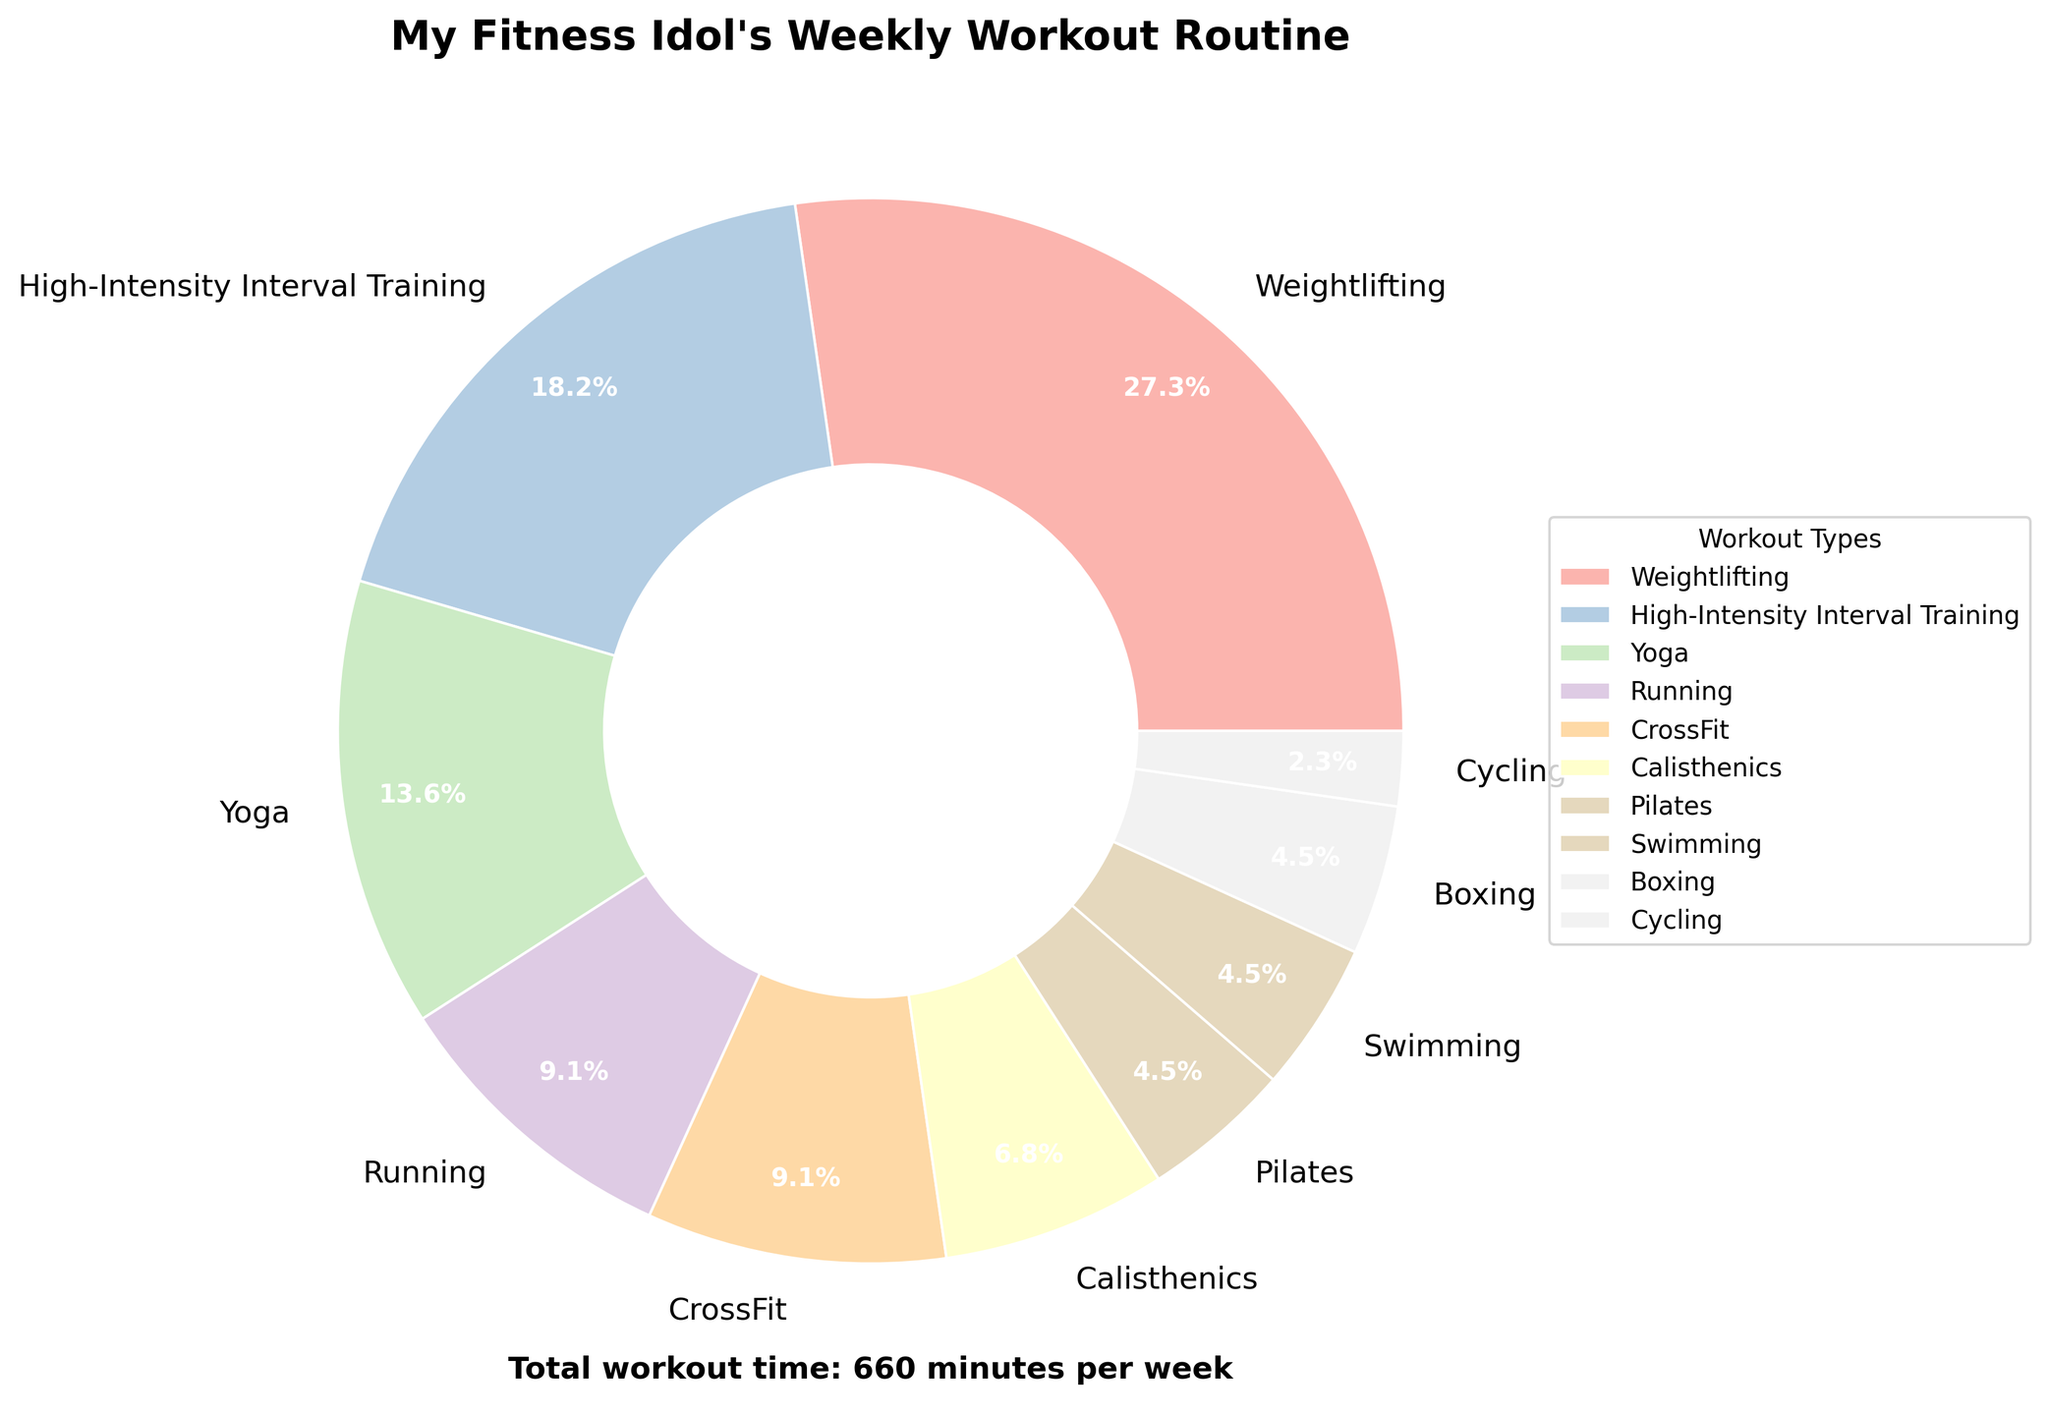How many workout types does the fitness influencer perform for less than an hour a week? There are multiple segments less than an hour. These include Calisthenics (45 min), Pilates (30 min), Swimming (30 min), Boxing (30 min), and Cycling (15 min). So, 5 workout types are less than an hour.
Answer: 5 Which workout type occupies the largest segment in the pie chart? The pie chart shows that the largest segment is Weightlifting.
Answer: Weightlifting What is the total percentage of time spent on Weightlifting and High-Intensity Interval Training combined? Weightlifting takes up 37.5% (180 out of total 480 min) and High-Intensity Interval Training takes up 25% (120 out of 480 min). So, combined it is 37.5% + 25% = 62.5%.
Answer: 62.5% How many workout minutes does the influencer spend on Running compared to Boxing? Running and Boxing both are indicated as 60 minutes and 30 minutes respectively. So, Running is (60 - 30) more than Boxing.
Answer: 30 more minutes Arrange the following workout types in descending order of the time spent: Yoga, Running, CrossFit, and Pilates. The time distribution is: Yoga (90), Running (60), CrossFit (60), and Pilates (30). Arranged in descending order: Yoga, Running, CrossFit, and Pilates.
Answer: Yoga, Running, CrossFit, Pilates What percentage of the week does the influencer spend on Calisthenics, Pilates, Swimming, Boxing, and Cycling combined? Added time is 45 (Calisthenics) + 30 (Pilates) + 30 (Swimming) + 30 (Boxing) + 15 (Cycling) = 150 minutes. The total time is 480 minutes. So, the percent is (150/480) * 100 = 31.25%.
Answer: 31.25% What is the second most prominent workout type according to the pie chart? The pie chart shows that after Weightlifting (the largest), High-Intensity Interval Training appears to second largest.
Answer: High-Intensity Interval Training How much less time does the influencer spend on Yoga compared to all other workout types combined? Yoga takes up 90 minutes. The total time spent on workouts is 480 minutes, thus the time spent on all other workouts is 480 - 90 = 390 minutes. Therefore, Yoga time is (390 - 90) less than the sum of others.
Answer: 300 minutes less How does the time spent on Swimming compare to Cycling? Swimming and Cycling times both segments show 30 minutes and 15 minutes respectively. Swimming takes double of Cycling.
Answer: Double What percentage of the total workout time is spent on activities that involve equipment (Weightlifting, HIIT, CrossFit, Boxing, Cycling)? These workout times in their segments are respectively 180 (Weightlifting) + 120 (HIIT) + 60 (CrossFit) + 30 (Boxing) + 15 (Cycling) = 405 total minutes. The total workout time is 480 minutes. Percentage is (405/480) * 100 = 84.375%.
Answer: 84.375% 